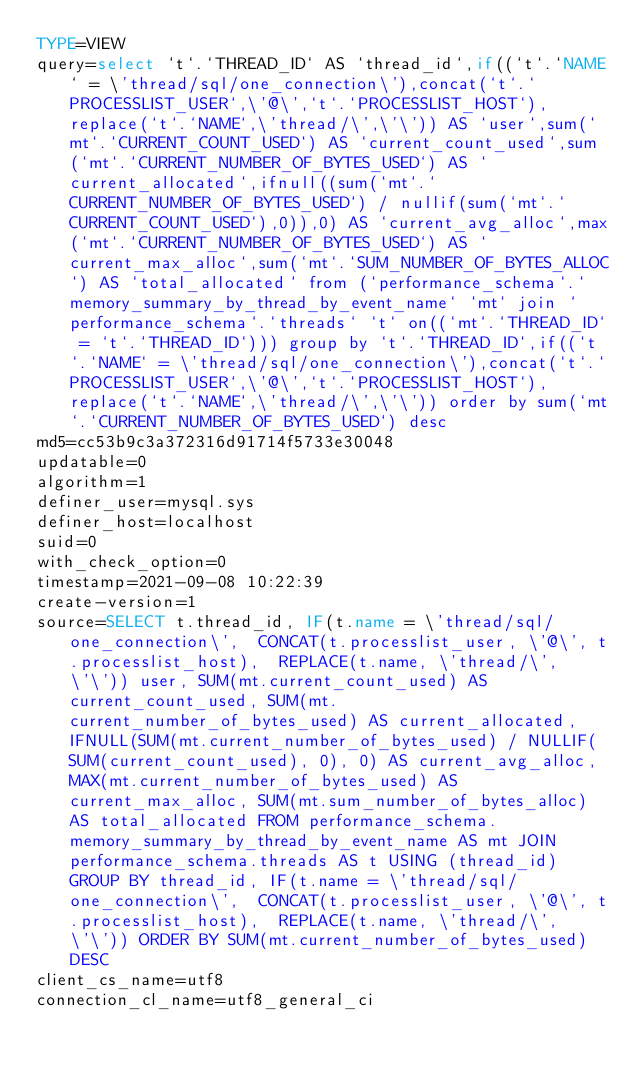Convert code to text. <code><loc_0><loc_0><loc_500><loc_500><_VisualBasic_>TYPE=VIEW
query=select `t`.`THREAD_ID` AS `thread_id`,if((`t`.`NAME` = \'thread/sql/one_connection\'),concat(`t`.`PROCESSLIST_USER`,\'@\',`t`.`PROCESSLIST_HOST`),replace(`t`.`NAME`,\'thread/\',\'\')) AS `user`,sum(`mt`.`CURRENT_COUNT_USED`) AS `current_count_used`,sum(`mt`.`CURRENT_NUMBER_OF_BYTES_USED`) AS `current_allocated`,ifnull((sum(`mt`.`CURRENT_NUMBER_OF_BYTES_USED`) / nullif(sum(`mt`.`CURRENT_COUNT_USED`),0)),0) AS `current_avg_alloc`,max(`mt`.`CURRENT_NUMBER_OF_BYTES_USED`) AS `current_max_alloc`,sum(`mt`.`SUM_NUMBER_OF_BYTES_ALLOC`) AS `total_allocated` from (`performance_schema`.`memory_summary_by_thread_by_event_name` `mt` join `performance_schema`.`threads` `t` on((`mt`.`THREAD_ID` = `t`.`THREAD_ID`))) group by `t`.`THREAD_ID`,if((`t`.`NAME` = \'thread/sql/one_connection\'),concat(`t`.`PROCESSLIST_USER`,\'@\',`t`.`PROCESSLIST_HOST`),replace(`t`.`NAME`,\'thread/\',\'\')) order by sum(`mt`.`CURRENT_NUMBER_OF_BYTES_USED`) desc
md5=cc53b9c3a372316d91714f5733e30048
updatable=0
algorithm=1
definer_user=mysql.sys
definer_host=localhost
suid=0
with_check_option=0
timestamp=2021-09-08 10:22:39
create-version=1
source=SELECT t.thread_id, IF(t.name = \'thread/sql/one_connection\',  CONCAT(t.processlist_user, \'@\', t.processlist_host),  REPLACE(t.name, \'thread/\', \'\')) user, SUM(mt.current_count_used) AS current_count_used, SUM(mt.current_number_of_bytes_used) AS current_allocated, IFNULL(SUM(mt.current_number_of_bytes_used) / NULLIF(SUM(current_count_used), 0), 0) AS current_avg_alloc, MAX(mt.current_number_of_bytes_used) AS current_max_alloc, SUM(mt.sum_number_of_bytes_alloc) AS total_allocated FROM performance_schema.memory_summary_by_thread_by_event_name AS mt JOIN performance_schema.threads AS t USING (thread_id) GROUP BY thread_id, IF(t.name = \'thread/sql/one_connection\',  CONCAT(t.processlist_user, \'@\', t.processlist_host),  REPLACE(t.name, \'thread/\', \'\')) ORDER BY SUM(mt.current_number_of_bytes_used) DESC
client_cs_name=utf8
connection_cl_name=utf8_general_ci</code> 